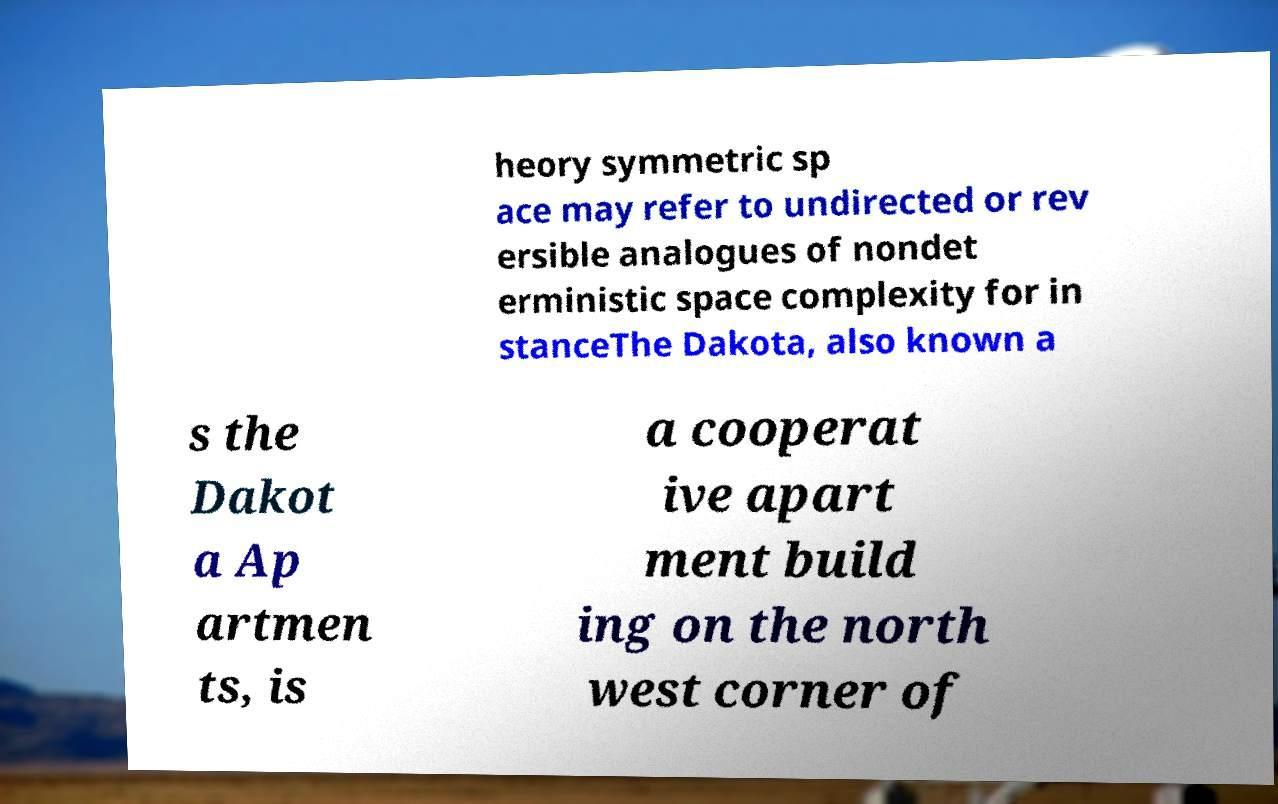I need the written content from this picture converted into text. Can you do that? heory symmetric sp ace may refer to undirected or rev ersible analogues of nondet erministic space complexity for in stanceThe Dakota, also known a s the Dakot a Ap artmen ts, is a cooperat ive apart ment build ing on the north west corner of 